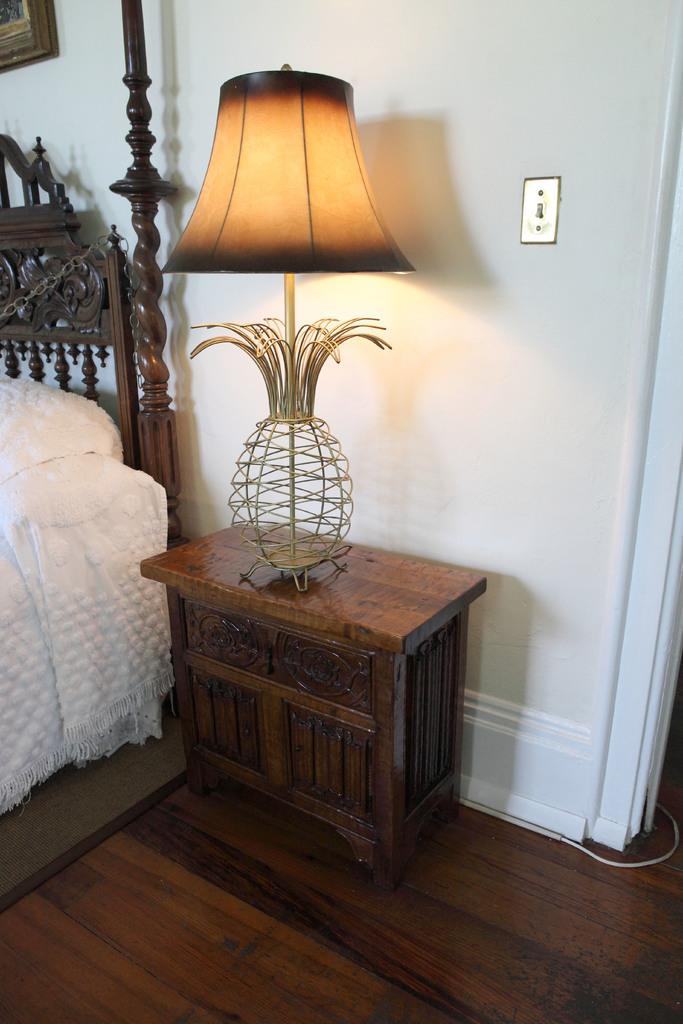What piece of furniture is on the floor in the image? There is a table on the floor in the image. What is placed on the table? There is a lamp on the table. What type of furniture is in the image for sleeping? There is a bed in the image. What can be seen on the wall in the image? There is a frame on the wall in the image. How does the bed in the image show approval for the frame on the wall? The bed in the image does not show approval for the frame on the wall, as these concepts are not related in the image. 